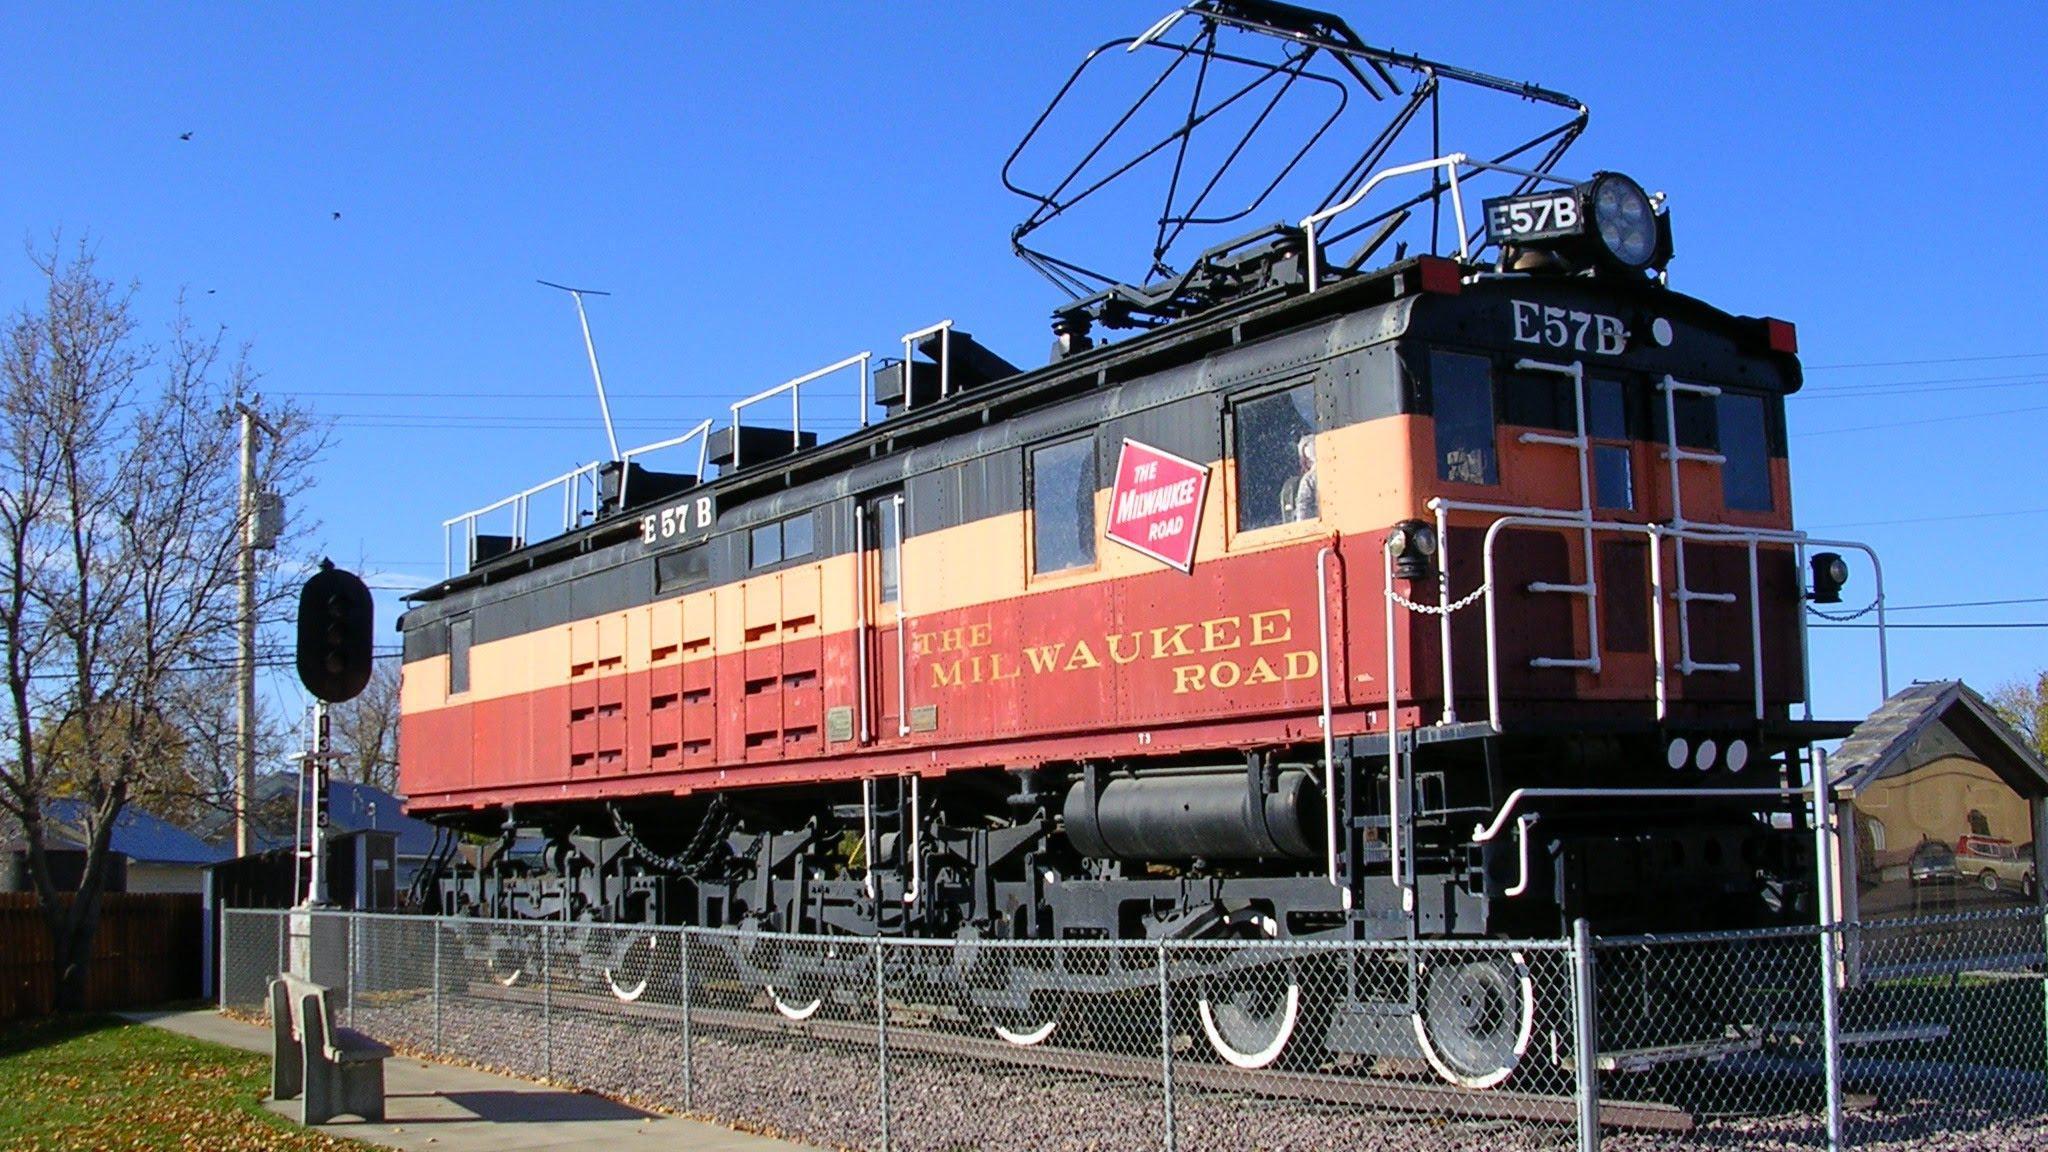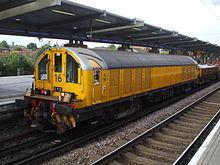The first image is the image on the left, the second image is the image on the right. Evaluate the accuracy of this statement regarding the images: "Both images show a train with at least one train car, and both trains are headed in the same direction and will not collide.". Is it true? Answer yes or no. No. The first image is the image on the left, the second image is the image on the right. For the images shown, is this caption "The train in on the track in the image on the right is primarily yellow." true? Answer yes or no. Yes. 